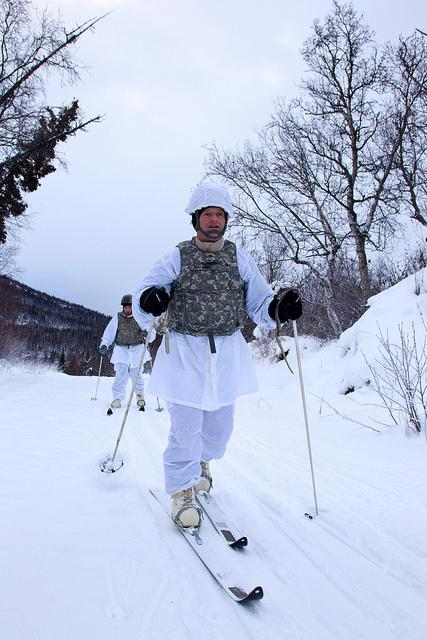Why does he have on that type of vest?

Choices:
A) avoiding bullet
B) blending in
C) standing out
D) carry items blending in 